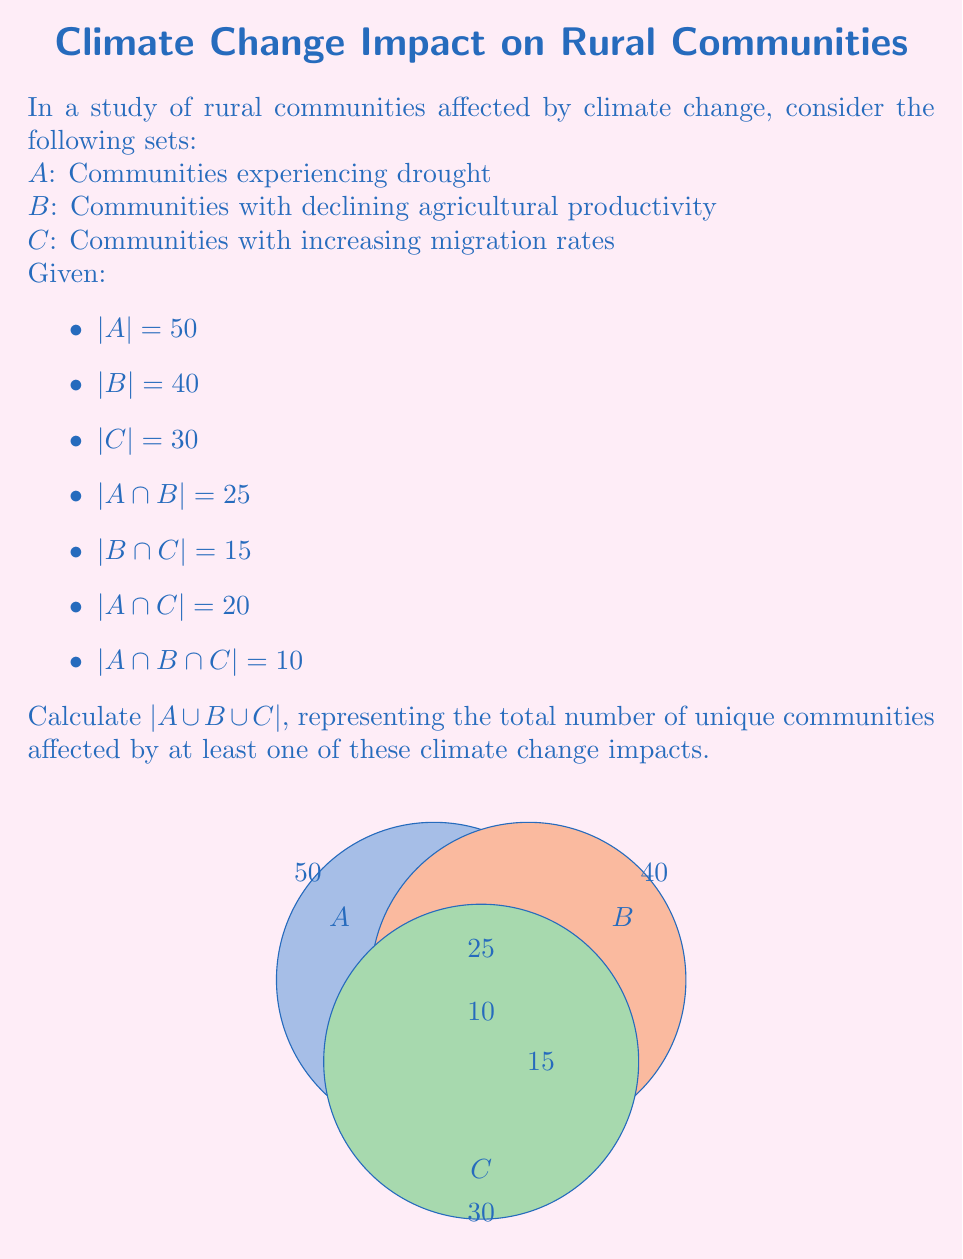Teach me how to tackle this problem. To solve this problem, we'll use the Inclusion-Exclusion Principle for three sets:

$$|A \cup B \cup C| = |A| + |B| + |C| - |A \cap B| - |B \cap C| - |A \cap C| + |A \cap B \cap C|$$

Let's substitute the given values:

1) $|A| = 50$
2) $|B| = 40$
3) $|C| = 30$
4) $|A \cap B| = 25$
5) $|B \cap C| = 15$
6) $|A \cap C| = 20$
7) $|A \cap B \cap C| = 10$

Now, let's calculate:

$$\begin{align*}
|A \cup B \cup C| &= 50 + 40 + 30 - 25 - 15 - 20 + 10 \\
&= 120 - 60 + 10 \\
&= 70
\end{align*}$$

Therefore, the total number of unique communities affected by at least one of these climate change impacts is 70.

This result demonstrates the complex interplay between different ecological and sociological factors in rural communities affected by climate change. It shows that while individual impacts may affect many communities, there is significant overlap, and some communities are affected by multiple impacts simultaneously.
Answer: 70 communities 